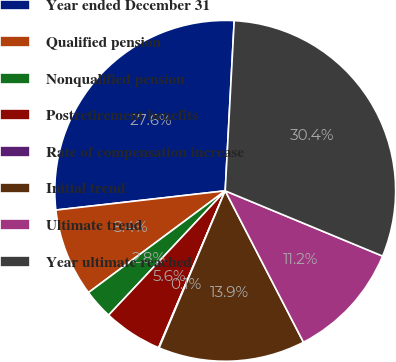<chart> <loc_0><loc_0><loc_500><loc_500><pie_chart><fcel>Year ended December 31<fcel>Qualified pension<fcel>Nonqualified pension<fcel>Postretirement benefits<fcel>Rate of compensation increase<fcel>Initial trend<fcel>Ultimate trend<fcel>Year ultimate reached<nl><fcel>27.64%<fcel>8.38%<fcel>2.83%<fcel>5.6%<fcel>0.05%<fcel>13.93%<fcel>11.15%<fcel>30.41%<nl></chart> 